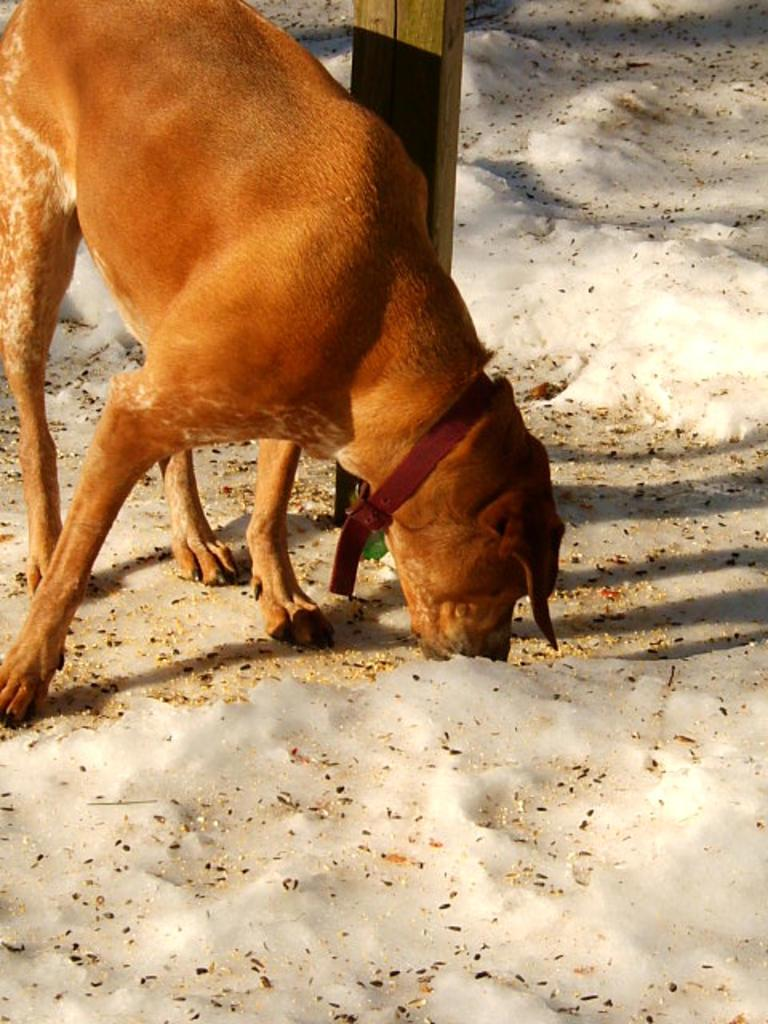What type of animal is present in the image? There is a dog in the image. Where is the dog located? The dog is on the ground. What other object can be seen in the image? There is a wooden pole in the image. What type of tree can be seen at the seashore in the image? There is no tree or seashore present in the image; it features a dog on the ground and a wooden pole. 